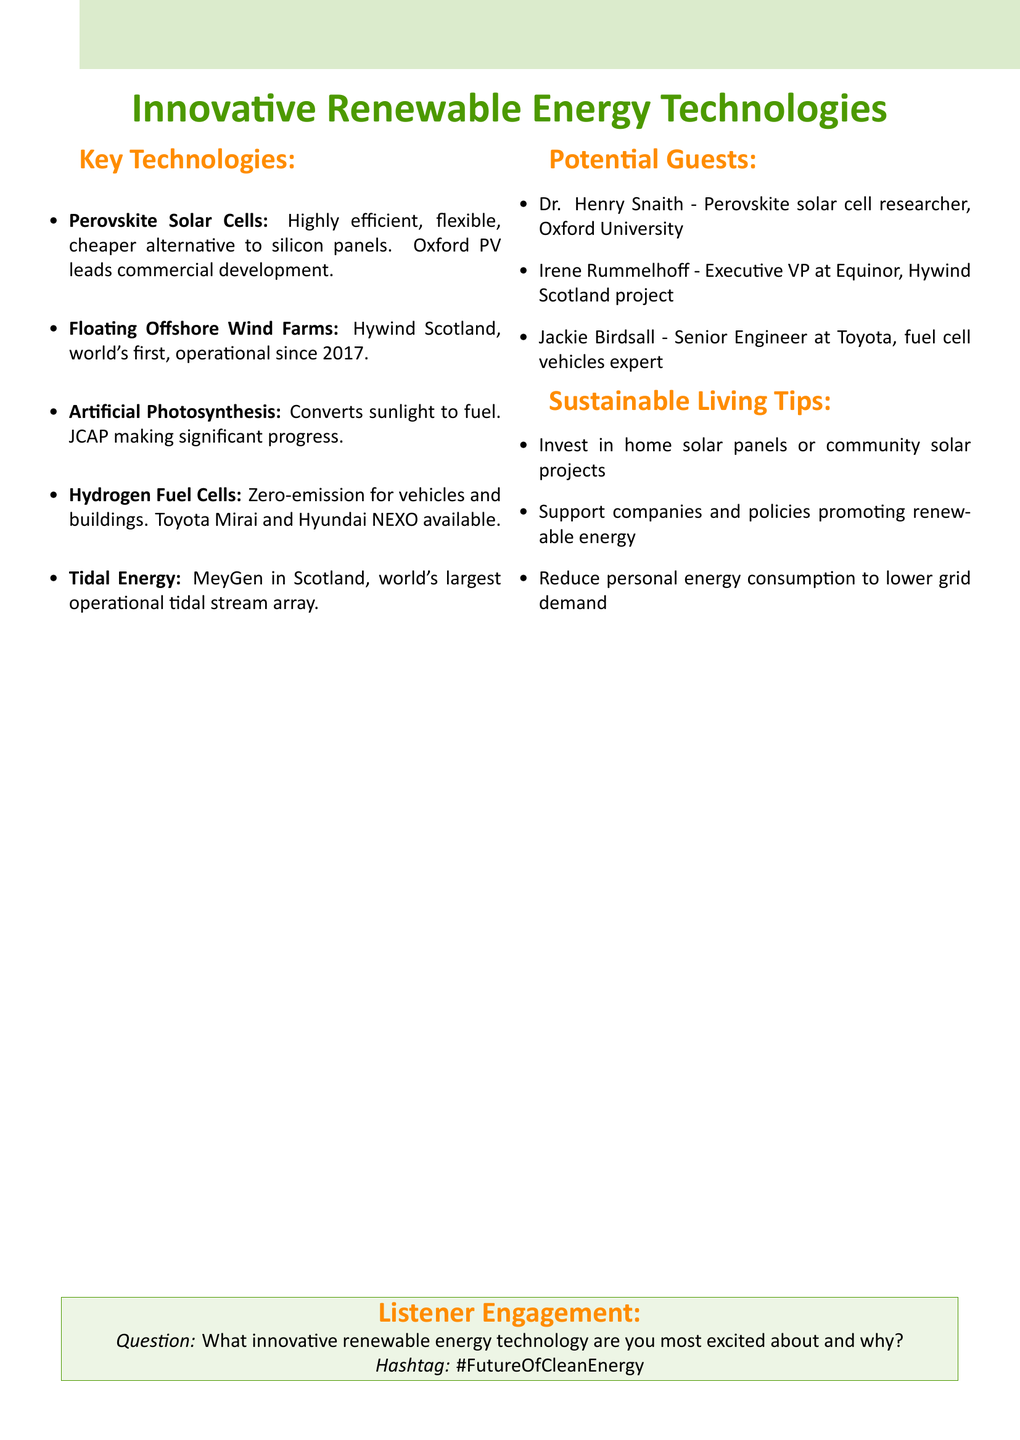What is the name of the company leading the commercial development of Perovskite Solar Cells? The document mentions Oxford PV as the leading commercial developer of Perovskite Solar Cells.
Answer: Oxford PV What year did the world's first floating wind farm become operational? The document states that Hywind Scotland, the world's first floating wind farm, has been operational since 2017.
Answer: 2017 Which project is described as the world's largest operational tidal stream array? The document refers to the MeyGen project in Scotland as the largest operational tidal stream array.
Answer: MeyGen What are the names of two commercially available hydrogen fuel cell vehicles? The document lists Toyota Mirai and Hyundai NEXO as commercially available fuel cell vehicles.
Answer: Toyota Mirai and Hyundai NEXO Who is the expert involved in the Hywind Scotland project? The document identifies Irene Rummelhoff as the Executive VP at Equinor, involved in the Hywind Scotland project.
Answer: Irene Rummelhoff What is the primary benefit of using Hydrogen Fuel Cells mentioned in the document? The document specifies that Hydrogen Fuel Cells are a zero-emission energy source for vehicles and buildings.
Answer: Zero-emission energy source What innovative technology mimics plant processes to convert sunlight into fuel? The document highlights Artificial Photosynthesis as the technology that mimics plant processes for fuel conversion.
Answer: Artificial Photosynthesis What is one sustainable living tip provided in the document? The document suggests investing in home solar panels or community solar projects as a tip for sustainable living.
Answer: Invest in home solar panels or community solar projects What question does the document propose for listener engagement? The document presents the question: "What innovative renewable energy technology are you most excited about and why?" for listener engagement.
Answer: What innovative renewable energy technology are you most excited about and why? 